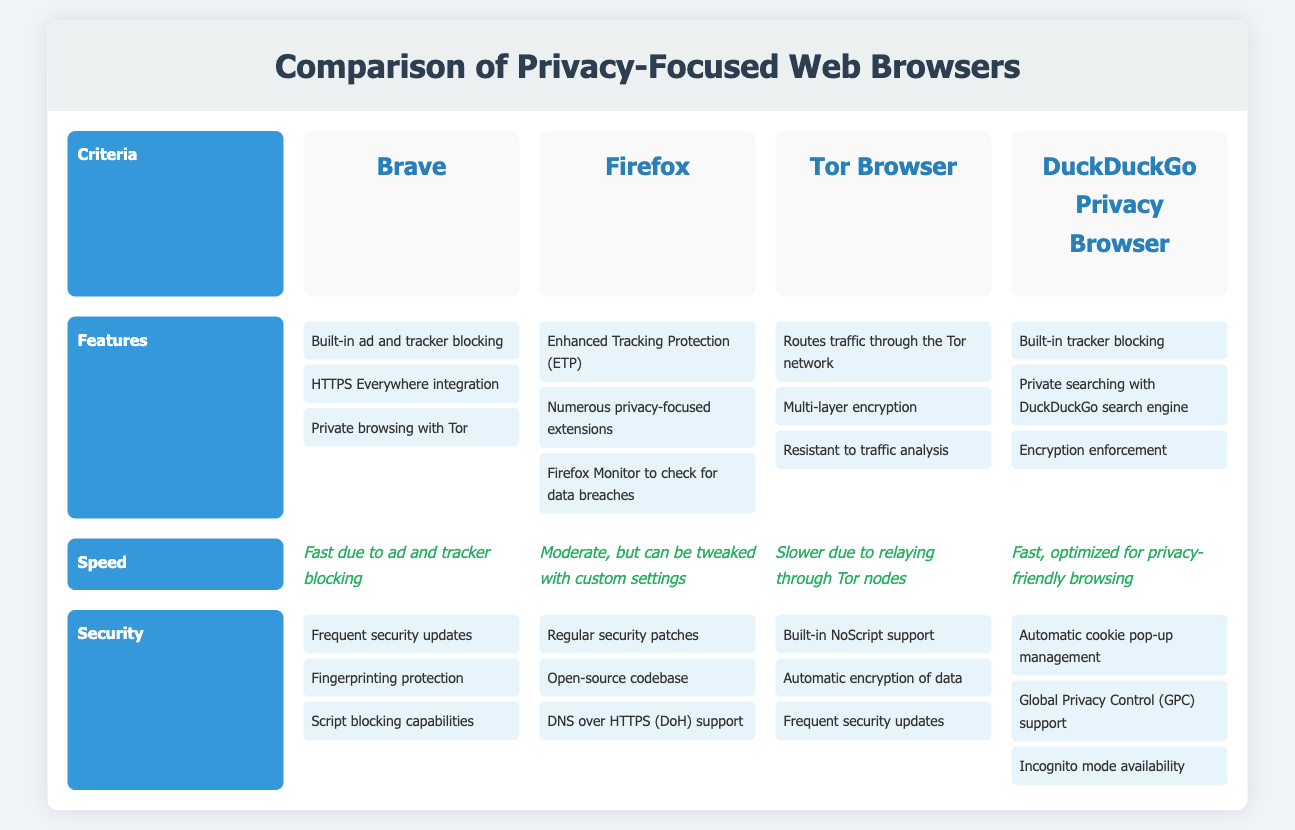What are the criteria compared in the infographic? The criteria compared include Features, Speed, and Security.
Answer: Features, Speed, Security Which browser has built-in ad and tracker blocking? The document lists Brave, DuckDuckGo Privacy Browser, and Tor Browser as having built-in ad and tracker blocking.
Answer: Brave, DuckDuckGo Privacy Browser, Tor Browser Which browser routes traffic through the Tor network? The document indicates that the Tor Browser routes traffic through the Tor network.
Answer: Tor Browser What is the speed of Brave browser according to the document? The document states that Brave is fast due to ad and tracker blocking.
Answer: Fast What security feature is supported by Firefox? The document mentions that Firefox supports DNS over HTTPS (DoH).
Answer: DNS over HTTPS (DoH) Which two browsers are noted for slower speed? The document indicates that Tor Browser is slower due to relaying through Tor nodes, and Firefox can be slowed down with custom settings.
Answer: Tor Browser, Firefox What is a shared feature of Brave and DuckDuckGo Privacy Browser? The document shows that both browsers have built-in tracker blocking as a feature.
Answer: Built-in tracker blocking Which browser has multi-layer encryption? The document states that multi-layer encryption is a feature of the Tor Browser.
Answer: Tor Browser What is the security feature of DuckDuckGo Privacy Browser? The document highlights that DuckDuckGo Privacy Browser has automatic cookie pop-up management.
Answer: Automatic cookie pop-up management 